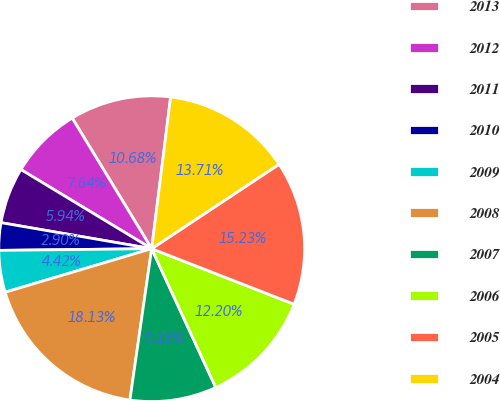Convert chart. <chart><loc_0><loc_0><loc_500><loc_500><pie_chart><fcel>2013<fcel>2012<fcel>2011<fcel>2010<fcel>2009<fcel>2008<fcel>2007<fcel>2006<fcel>2005<fcel>2004<nl><fcel>10.68%<fcel>7.64%<fcel>5.94%<fcel>2.9%<fcel>4.42%<fcel>18.13%<fcel>9.16%<fcel>12.2%<fcel>15.23%<fcel>13.71%<nl></chart> 